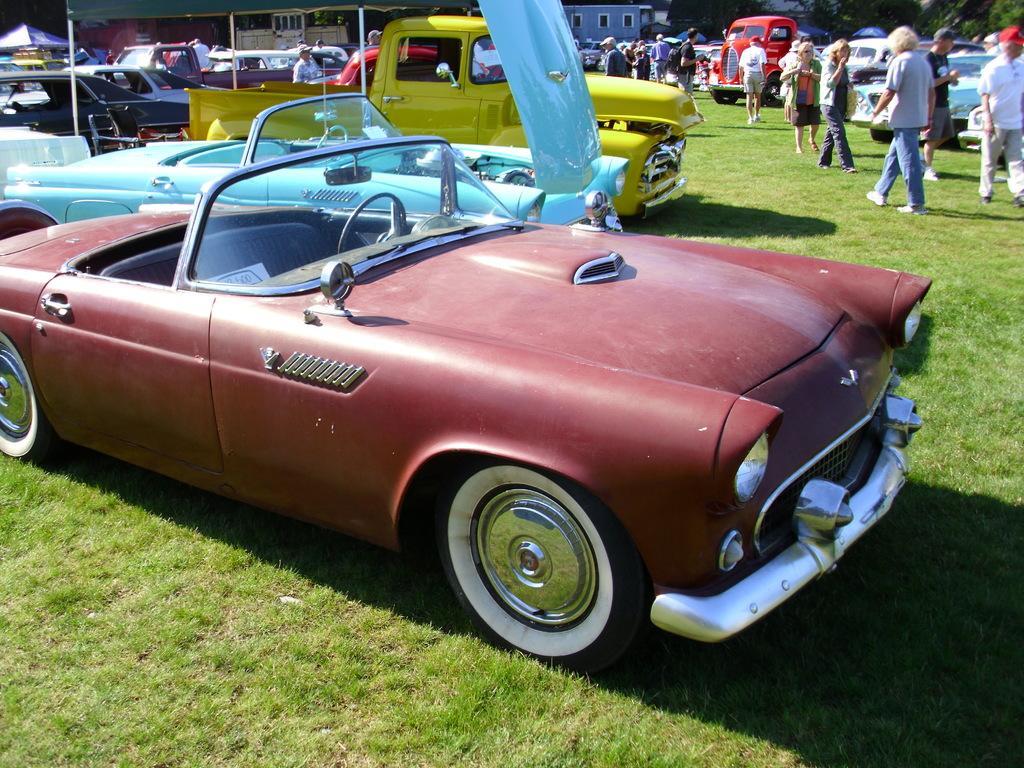Could you give a brief overview of what you see in this image? In the image I can see a place where we have some people and some cars on the grass and also I can see some buildings and poles. 